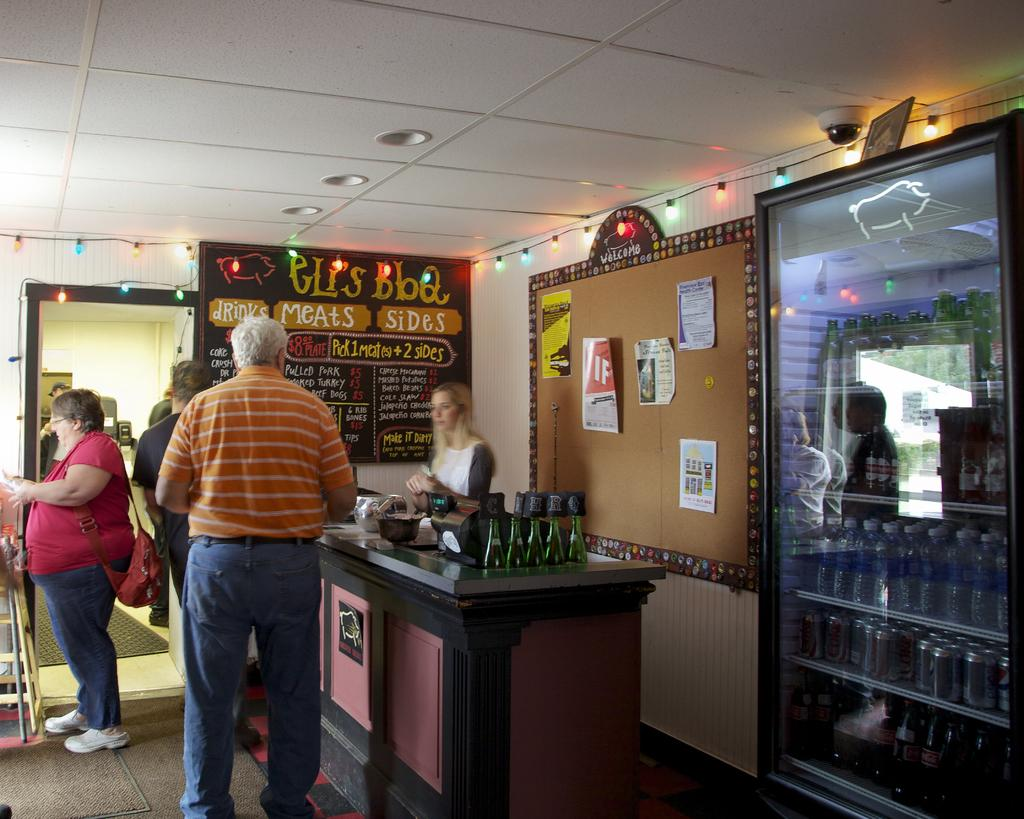How many people are in the image? There are many people in the image. Where are the people located in the image? The people are standing in a shop. What type of guitar can be seen in the image? There is no guitar present in the image; it features many people standing in a shop. What animals can be seen in the image? There are no animals present in the image, as it features people standing in a shop. 